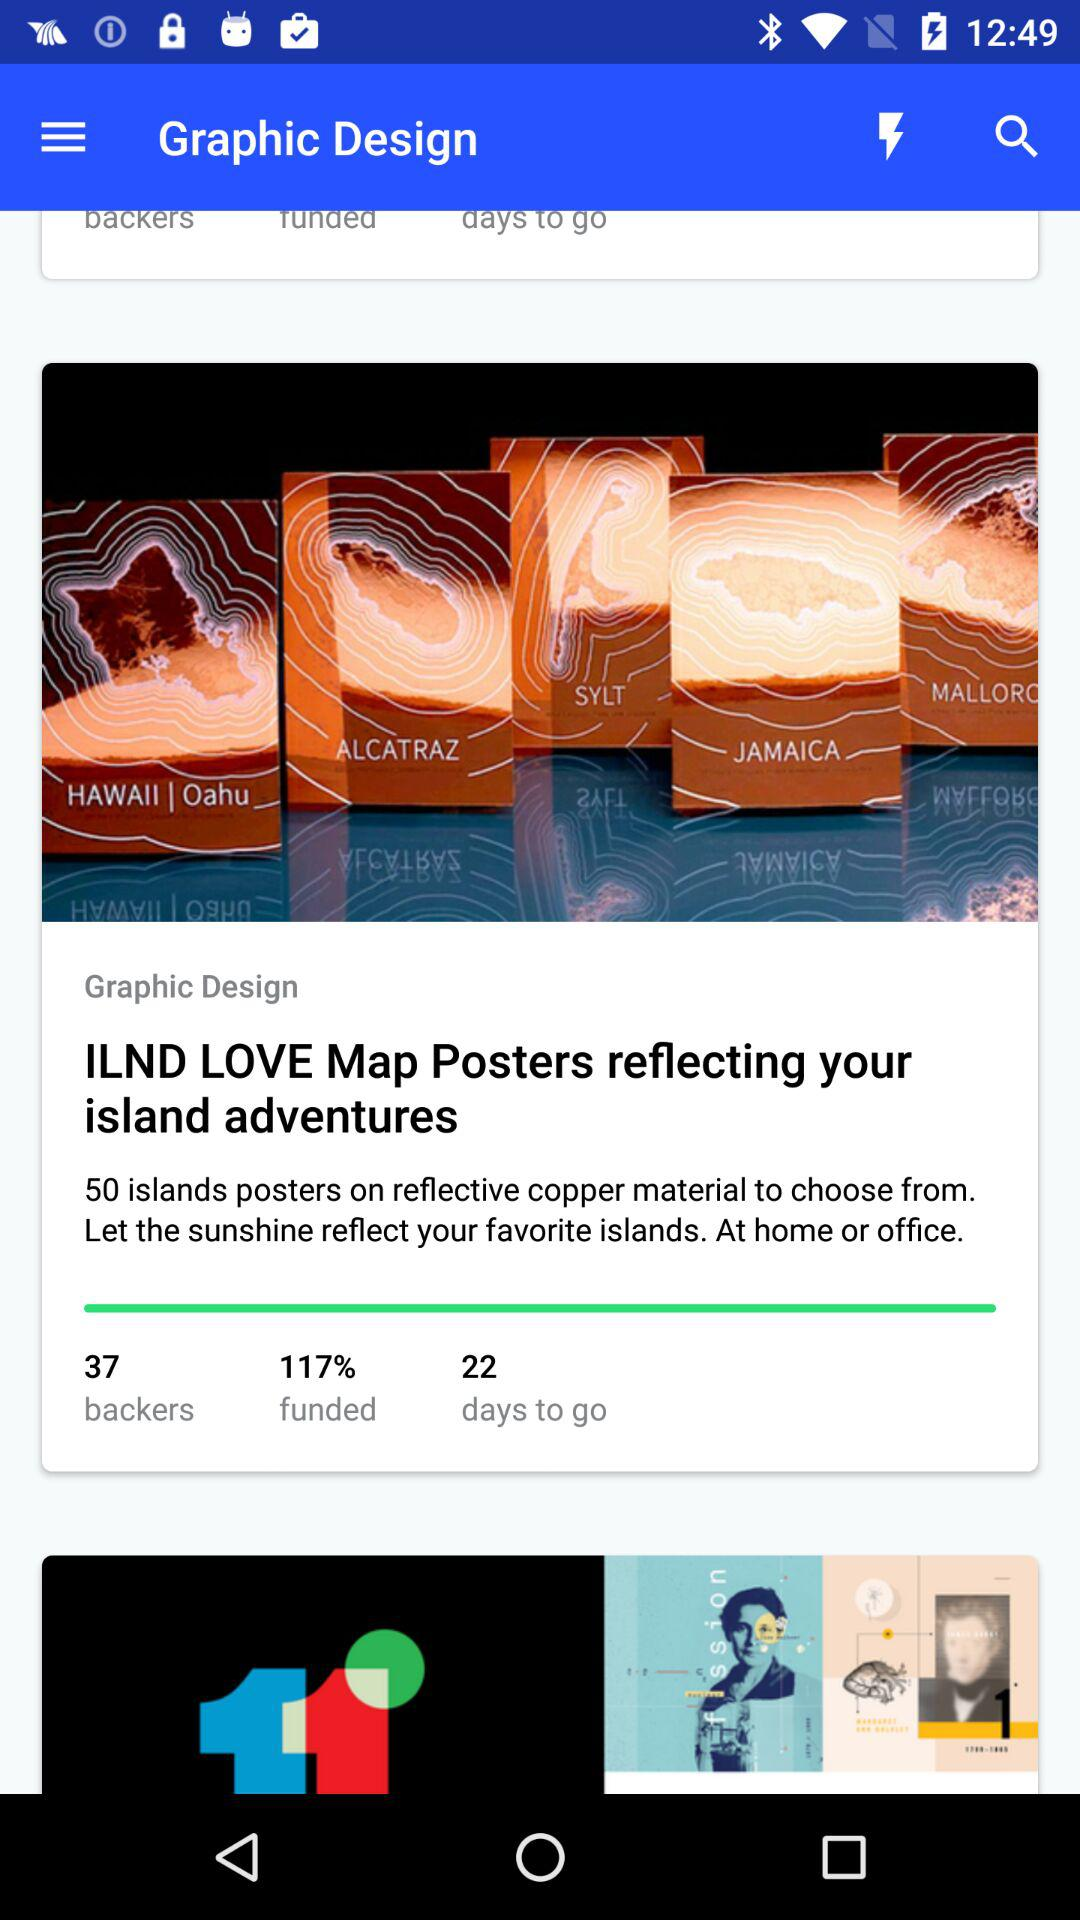What is the article name? The name is Graphic Design. 